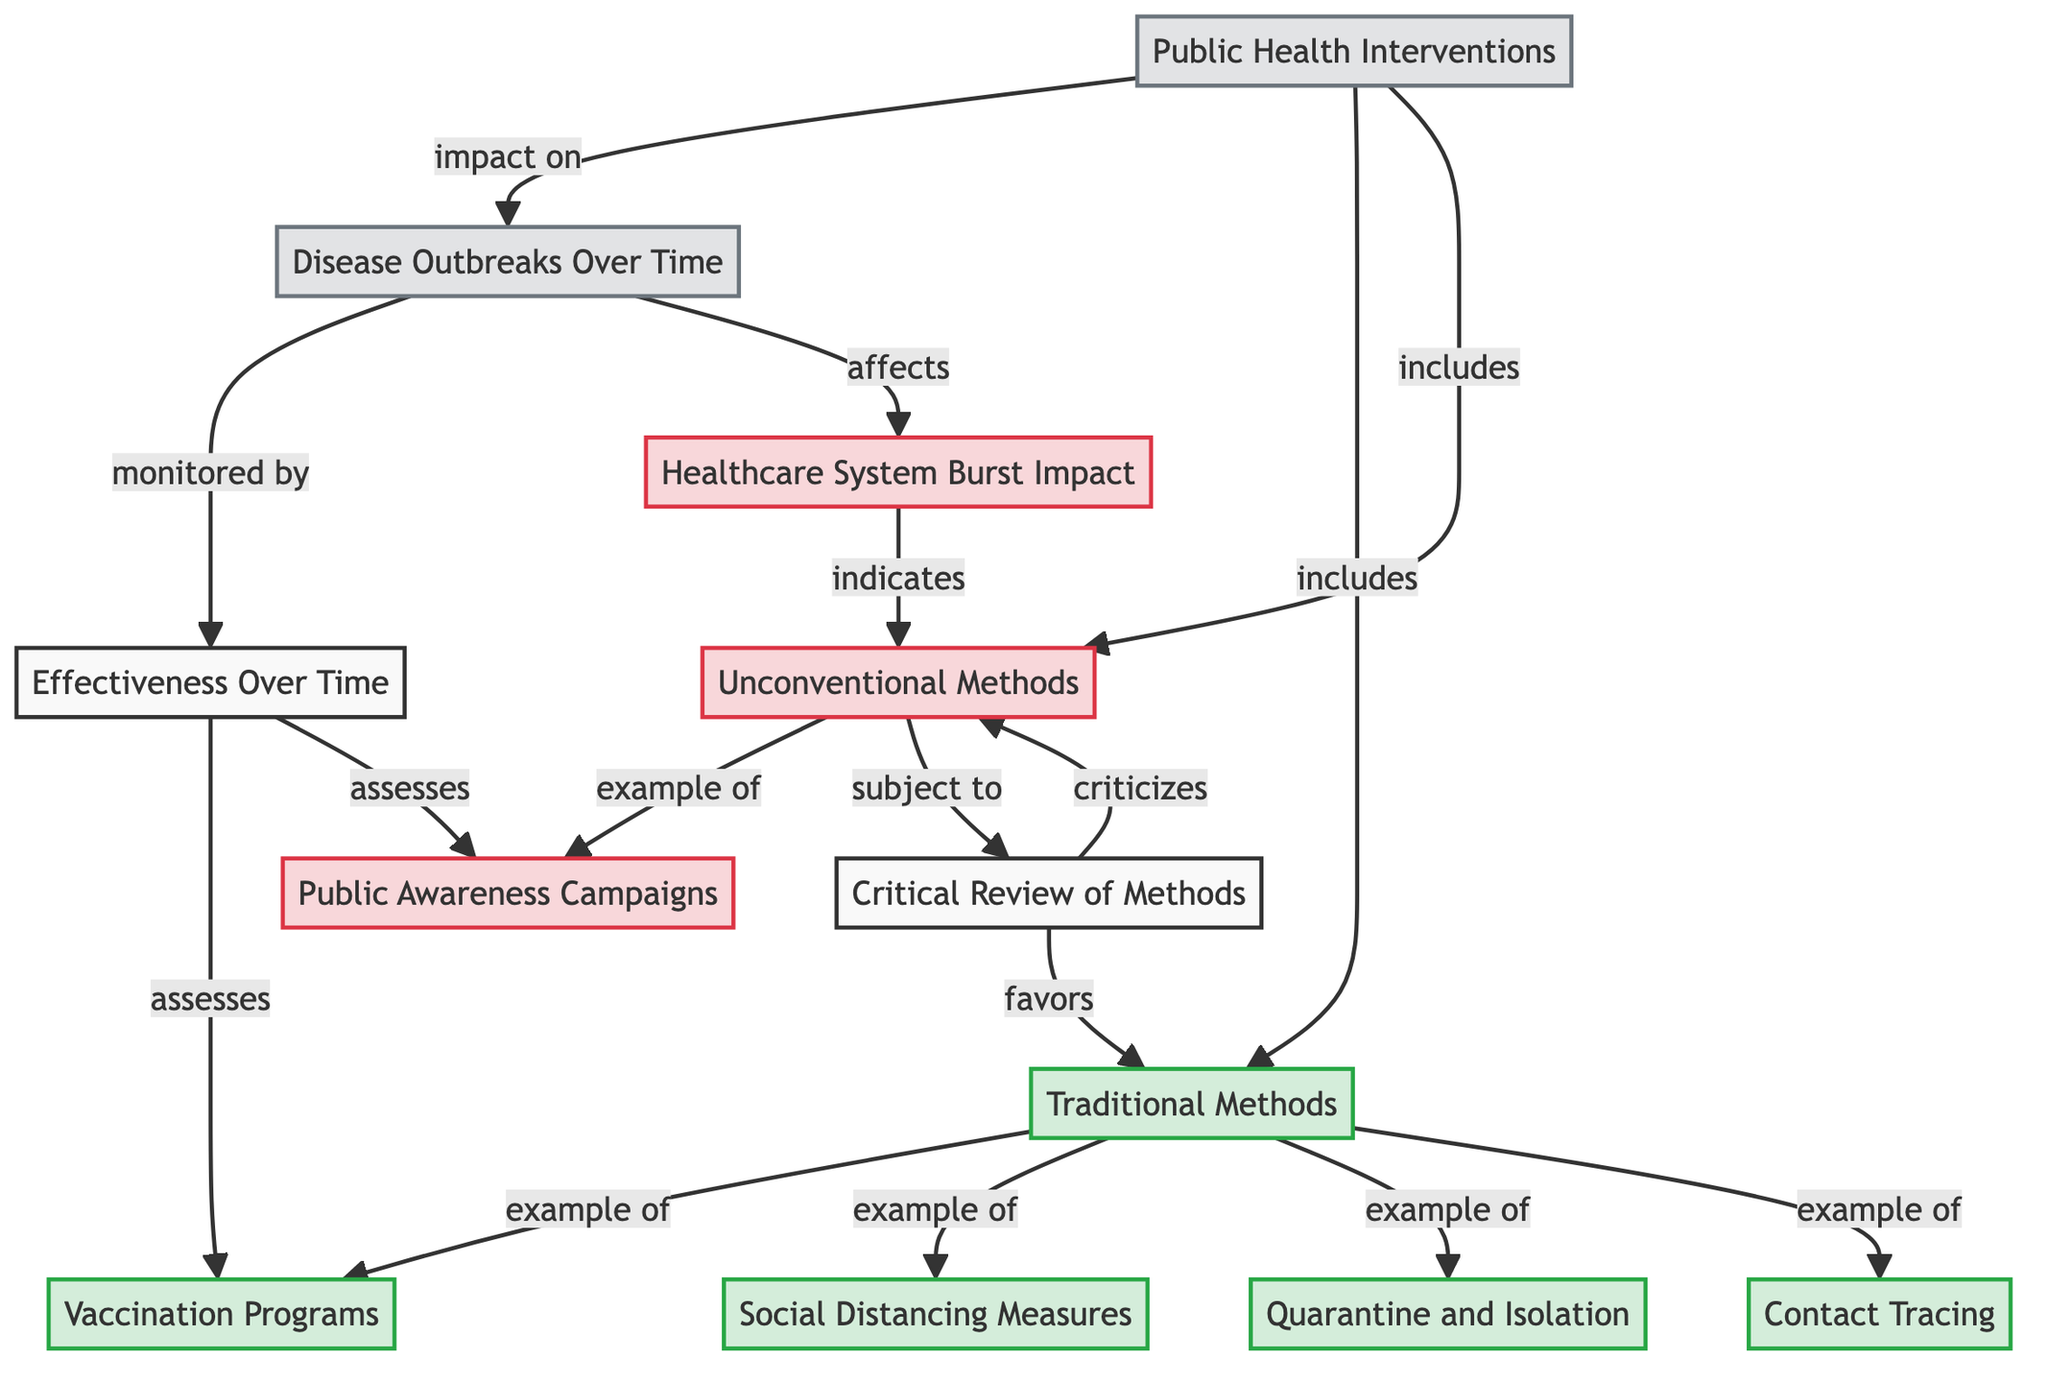What are the two main types of methods included under Public Health Interventions? The diagram illustrates that Public Health Interventions include two main types of methods: Traditional Methods and Unconventional Methods. This is indicated by the arrows leading from "Public Health Interventions" to both "Traditional Methods" and "Unconventional Methods."
Answer: Traditional Methods, Unconventional Methods Which traditional method is an example of a disease containment strategy? The diagram shows that Quarantine and Isolation is classified as an example of a Traditional Method in disease containment. It is connected to "Traditional Methods" through an arrow labeled "example of."
Answer: Quarantine and Isolation How many types of traditional methods are listed in the diagram? The diagram lists four examples of traditional methods: Vaccination Programs, Social Distancing Measures, Quarantine and Isolation, and Contact Tracing. Each method has an individual connection to the "Traditional Methods" node, which totals four.
Answer: Four What does the critical review of methods favor according to the diagram? The critical review of methods indicates a preference towards Traditional Methods, as illustrated by the arrow connecting "Critical Review of Methods" to "Traditional Methods" with the label "favors."
Answer: Traditional Methods Which intervention is criticized by the critical review of methods? According to the diagram, the critical review of methods criticizes the Unconventional Methods. This is shown by the arrow connecting "Critical Review of Methods" to "Unconventional Methods" labeled "criticizes."
Answer: Unconventional Methods Which two interventions are assessed for their effectiveness over time? The diagram specifies that the effectiveness over time is assessed for Vaccination Programs and Public Awareness Campaigns. Both interventions are connected with arrows from "Effectiveness Over Time" to their respective nodes.
Answer: Vaccination Programs, Public Awareness Campaigns What impact do Unconventional Methods have according to the diagram? The diagram indicates that Unconventional Methods have an effect that could lead to a Healthcare System Burst Impact, as shown by the arrow connecting "Healthcare System Burst Impact" to "Unconventional Methods" with the label "indicates."
Answer: Healthcare System Burst Impact How do Disease Outbreaks over time affect the healthcare system as per the diagram? The diagram illustrates a direct effect of Disease Outbreaks on the healthcare system, specifically through an arrow labeled "affects," which connects "Disease Outbreaks Over Time" to "Healthcare System Burst Impact."
Answer: Affects Healthcare System Burst Impact How are Public Awareness Campaigns categorized in this diagram? In the diagram, Public Awareness Campaigns are categorized under Unconventional Methods. It is linked to the node "Unconventional Methods" with an "example of" label, indicating its classification in that category.
Answer: Unconventional Methods 